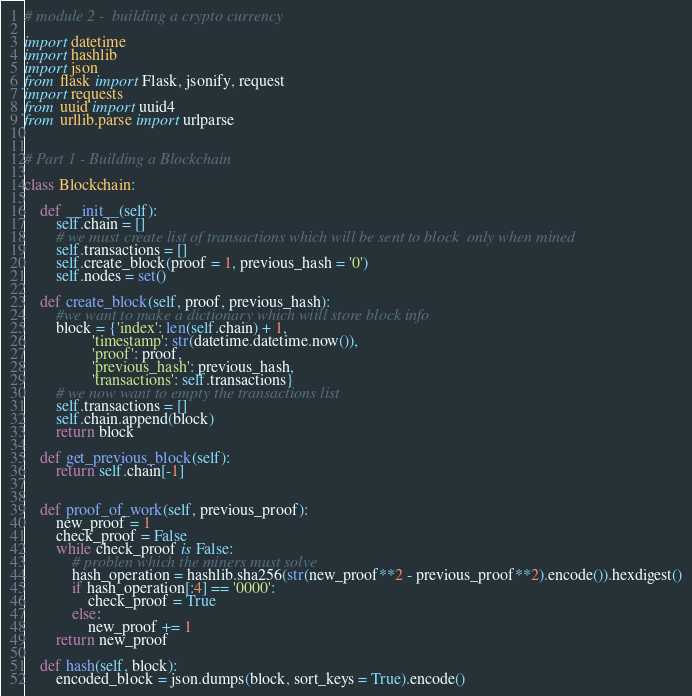Convert code to text. <code><loc_0><loc_0><loc_500><loc_500><_Python_># module 2 -  building a crypto currency

import datetime
import hashlib
import json
from flask import Flask, jsonify, request
import requests
from uuid import uuid4
from urllib.parse import urlparse


# Part 1 - Building a Blockchain

class Blockchain:

    def __init__(self):
        self.chain = []
        # we must create list of transactions which will be sent to block  only when mined
        self.transactions = []
        self.create_block(proof = 1, previous_hash = '0')
        self.nodes = set()

    def create_block(self, proof, previous_hash):
        #we want to make a dictionary which wiill store block info
        block = {'index': len(self.chain) + 1,
                 'timestamp': str(datetime.datetime.now()),
                 'proof': proof,
                 'previous_hash': previous_hash,
                 'transactions': self.transactions}
        # we now want to empty the transactions list
        self.transactions = []
        self.chain.append(block)
        return block

    def get_previous_block(self):
        return self.chain[-1]


    def proof_of_work(self, previous_proof):
        new_proof = 1
        check_proof = False
        while check_proof is False:
            # problen which the miners must solve
            hash_operation = hashlib.sha256(str(new_proof**2 - previous_proof**2).encode()).hexdigest()
            if hash_operation[:4] == '0000':
                check_proof = True
            else:
                new_proof += 1
        return new_proof
    
    def hash(self, block):
        encoded_block = json.dumps(block, sort_keys = True).encode()</code> 